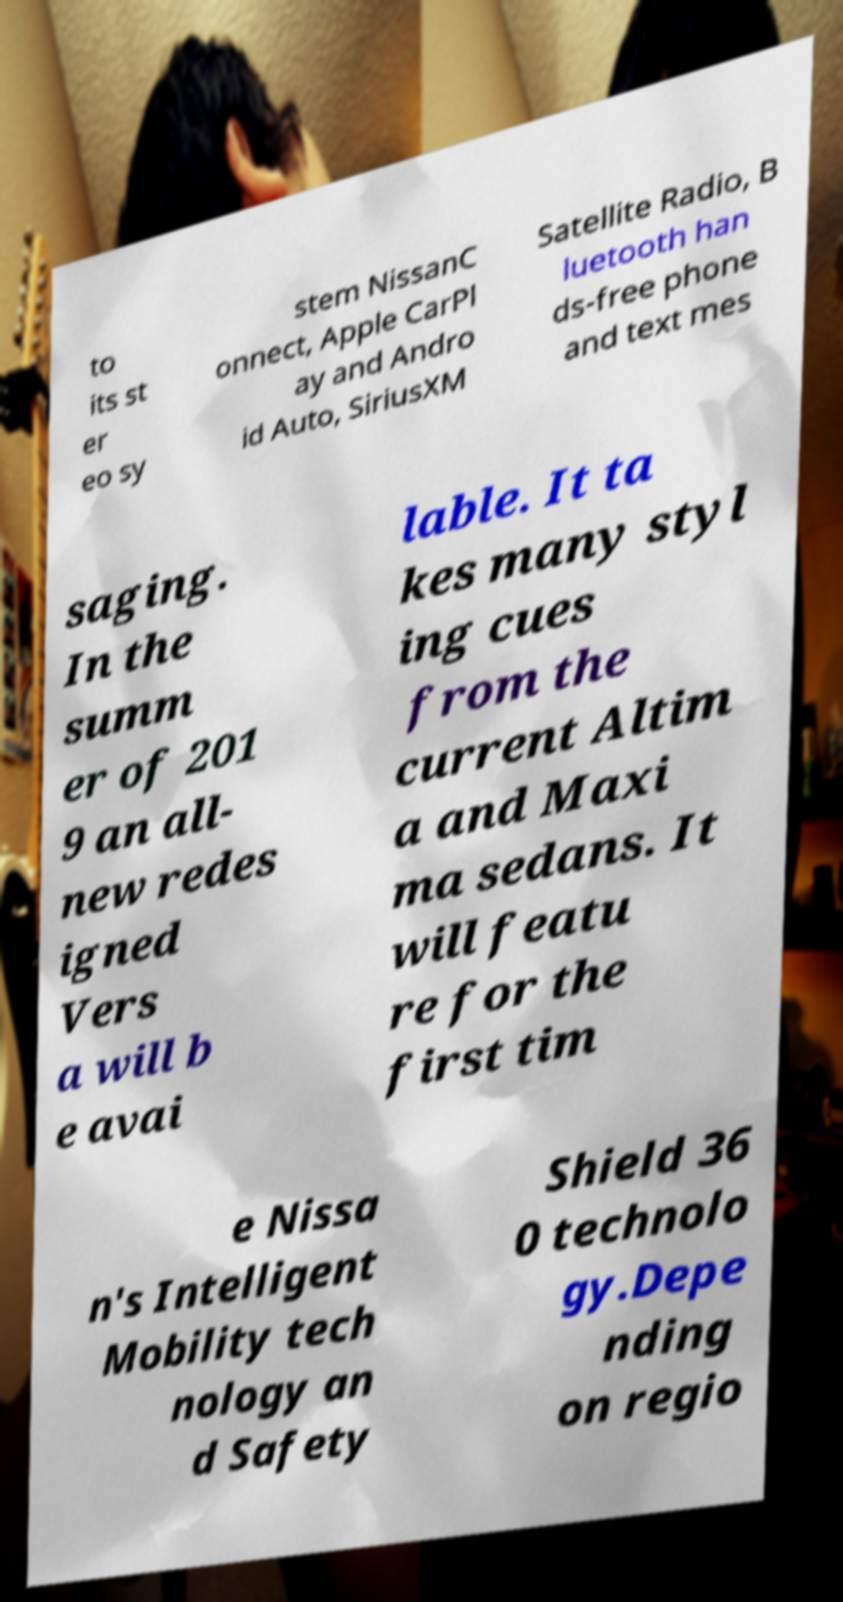There's text embedded in this image that I need extracted. Can you transcribe it verbatim? to its st er eo sy stem NissanC onnect, Apple CarPl ay and Andro id Auto, SiriusXM Satellite Radio, B luetooth han ds-free phone and text mes saging. In the summ er of 201 9 an all- new redes igned Vers a will b e avai lable. It ta kes many styl ing cues from the current Altim a and Maxi ma sedans. It will featu re for the first tim e Nissa n's Intelligent Mobility tech nology an d Safety Shield 36 0 technolo gy.Depe nding on regio 